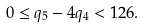Convert formula to latex. <formula><loc_0><loc_0><loc_500><loc_500>0 \leq q _ { 5 } - 4 q _ { 4 } < 1 2 6 .</formula> 